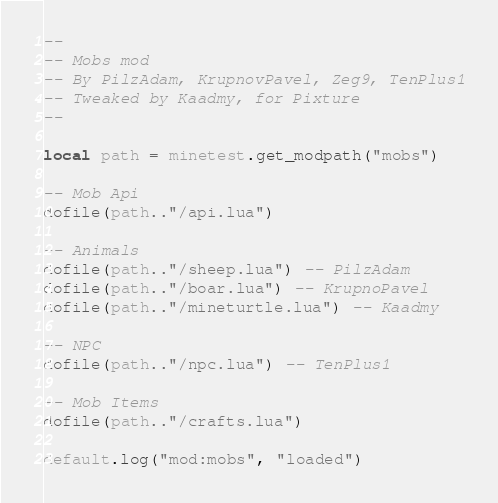Convert code to text. <code><loc_0><loc_0><loc_500><loc_500><_Lua_>--
-- Mobs mod
-- By PilzAdam, KrupnovPavel, Zeg9, TenPlus1
-- Tweaked by Kaadmy, for Pixture
--

local path = minetest.get_modpath("mobs")

-- Mob Api
dofile(path.."/api.lua")

-- Animals
dofile(path.."/sheep.lua") -- PilzAdam
dofile(path.."/boar.lua") -- KrupnoPavel
dofile(path.."/mineturtle.lua") -- Kaadmy

-- NPC
dofile(path.."/npc.lua") -- TenPlus1

-- Mob Items
dofile(path.."/crafts.lua")

default.log("mod:mobs", "loaded")
</code> 